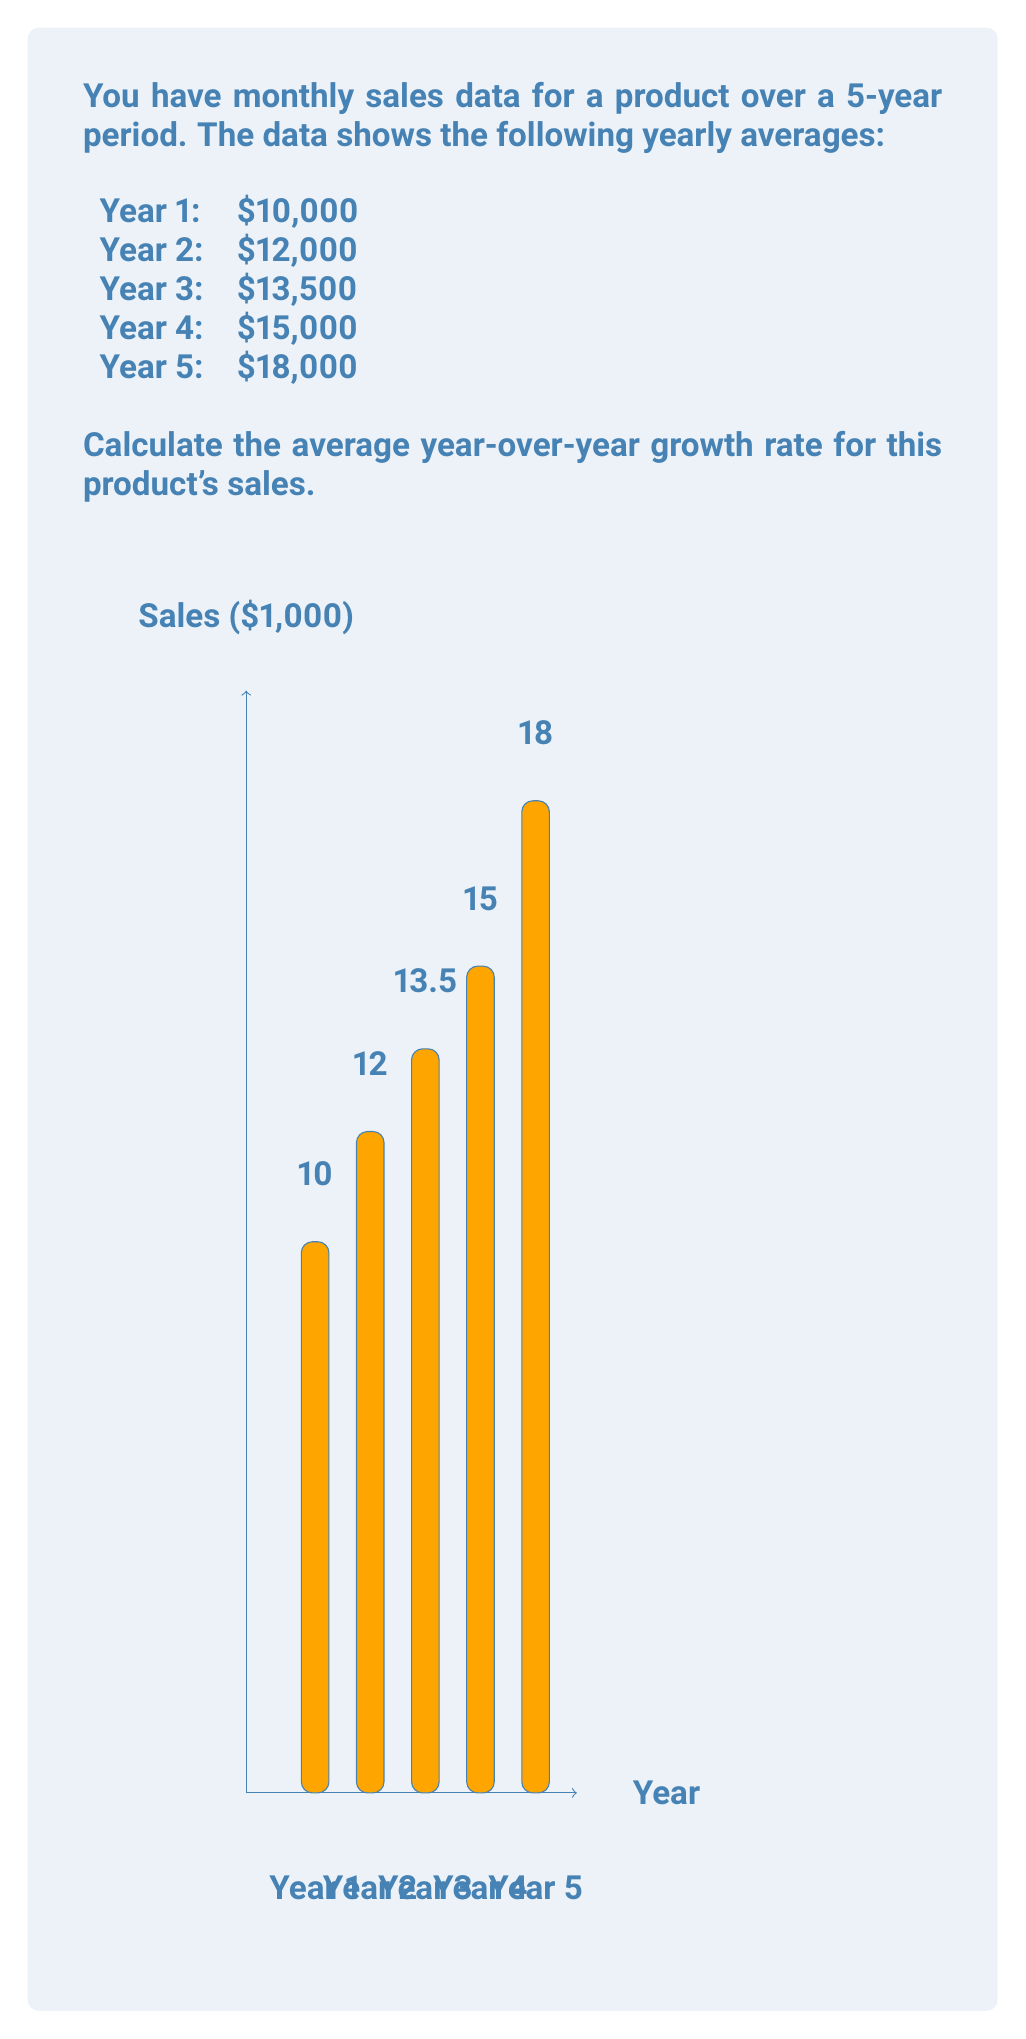Can you answer this question? To calculate the average year-over-year growth rate, we'll follow these steps:

1) Calculate the year-over-year growth rate for each year:

   Year 1 to Year 2: $\frac{12000 - 10000}{10000} = 0.20$ or 20%
   Year 2 to Year 3: $\frac{13500 - 12000}{12000} = 0.125$ or 12.5%
   Year 3 to Year 4: $\frac{15000 - 13500}{13500} = 0.1111$ or 11.11%
   Year 4 to Year 5: $\frac{18000 - 15000}{15000} = 0.20$ or 20%

2) Calculate the average of these growth rates:

   $\frac{0.20 + 0.125 + 0.1111 + 0.20}{4} = 0.1590$ or 15.90%

3) We can also verify this using the compound annual growth rate (CAGR) formula:

   $CAGR = \left(\frac{Final Value}{Initial Value}\right)^{\frac{1}{n}} - 1$

   Where $n$ is the number of years.

   $CAGR = \left(\frac{18000}{10000}\right)^{\frac{1}{4}} - 1 = 0.1589$ or 15.89%

The slight difference is due to rounding in our manual calculations.
Answer: 15.90% 